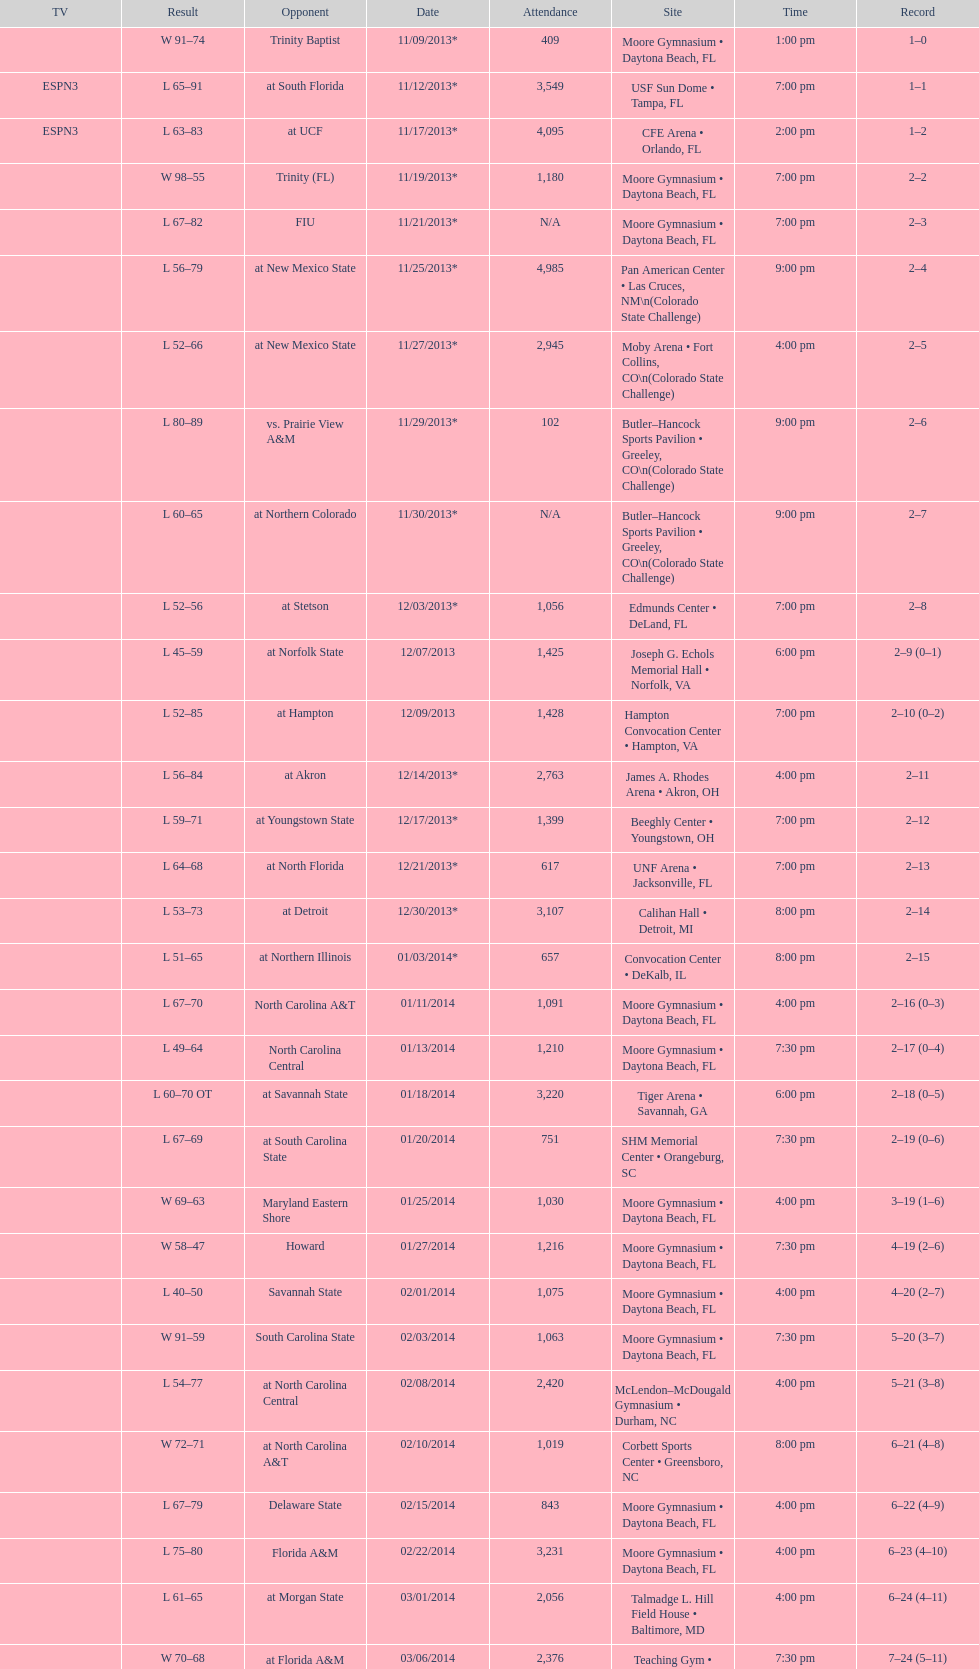What was the difference in attendance between 11/25/2013 and 12/21/2013? 4368. 